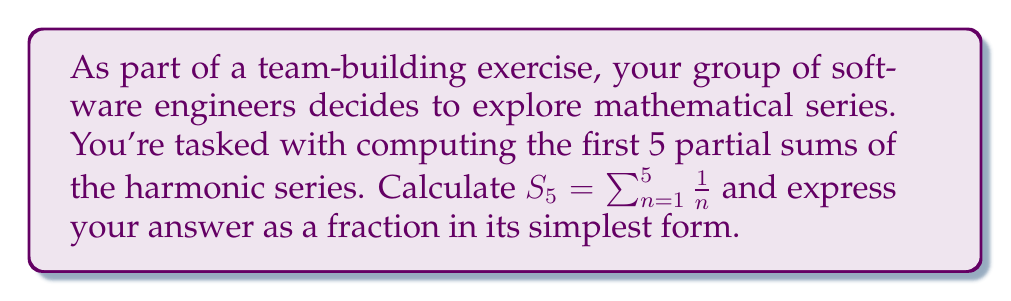What is the answer to this math problem? Let's approach this step-by-step:

1) The harmonic series is defined as: $\sum_{n=1}^{\infty} \frac{1}{n}$

2) We need to find $S_5$, which is the sum of the first 5 terms:

   $S_5 = \frac{1}{1} + \frac{1}{2} + \frac{1}{3} + \frac{1}{4} + \frac{1}{5}$

3) To add these fractions, we need a common denominator. The least common multiple of 1, 2, 3, 4, and 5 is 60.

4) Let's convert each fraction to an equivalent fraction with denominator 60:

   $\frac{1}{1} = \frac{60}{60}$
   $\frac{1}{2} = \frac{30}{60}$
   $\frac{1}{3} = \frac{20}{60}$
   $\frac{1}{4} = \frac{15}{60}$
   $\frac{1}{5} = \frac{12}{60}$

5) Now we can add these fractions:

   $S_5 = \frac{60}{60} + \frac{30}{60} + \frac{20}{60} + \frac{15}{60} + \frac{12}{60}$

6) Adding the numerators:

   $S_5 = \frac{60 + 30 + 20 + 15 + 12}{60} = \frac{137}{60}$

This fraction is already in its simplest form as 137 and 60 have no common factors other than 1.
Answer: $\frac{137}{60}$ 